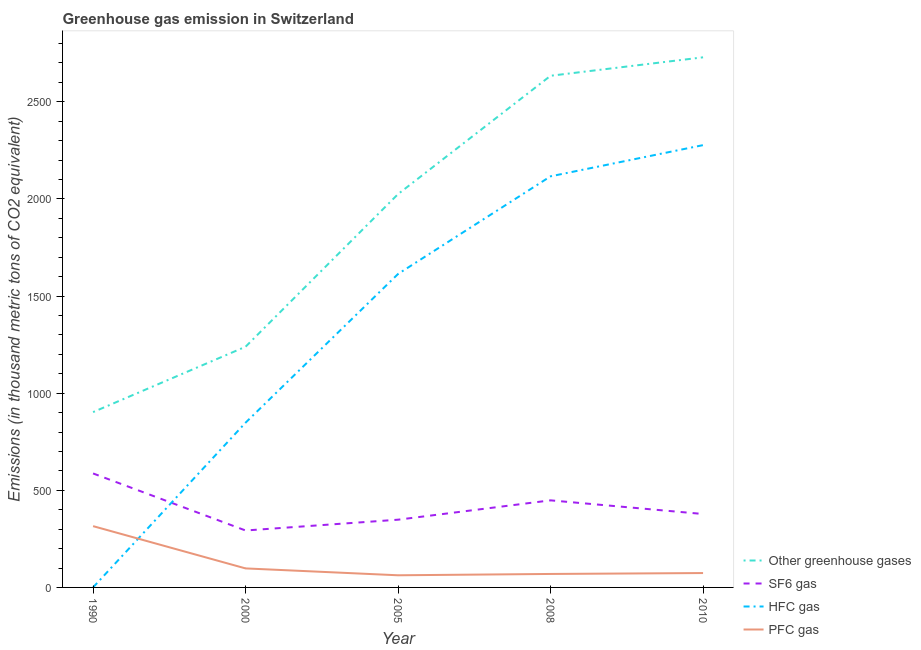Does the line corresponding to emission of hfc gas intersect with the line corresponding to emission of sf6 gas?
Make the answer very short. Yes. What is the emission of hfc gas in 2008?
Give a very brief answer. 2116.4. Across all years, what is the maximum emission of pfc gas?
Provide a short and direct response. 315.5. Across all years, what is the minimum emission of sf6 gas?
Offer a very short reply. 293.1. In which year was the emission of sf6 gas maximum?
Ensure brevity in your answer.  1990. In which year was the emission of pfc gas minimum?
Offer a very short reply. 2005. What is the total emission of sf6 gas in the graph?
Give a very brief answer. 2054.9. What is the difference between the emission of greenhouse gases in 2000 and that in 2008?
Your response must be concise. -1394.9. What is the difference between the emission of pfc gas in 2000 and the emission of sf6 gas in 2008?
Make the answer very short. -350.4. What is the average emission of sf6 gas per year?
Keep it short and to the point. 410.98. In the year 2005, what is the difference between the emission of hfc gas and emission of sf6 gas?
Provide a succinct answer. 1265.1. What is the ratio of the emission of hfc gas in 1990 to that in 2005?
Keep it short and to the point. 0. Is the emission of pfc gas in 1990 less than that in 2005?
Keep it short and to the point. No. What is the difference between the highest and the second highest emission of pfc gas?
Your answer should be compact. 217.6. What is the difference between the highest and the lowest emission of sf6 gas?
Your response must be concise. 293.7. In how many years, is the emission of greenhouse gases greater than the average emission of greenhouse gases taken over all years?
Keep it short and to the point. 3. Is the sum of the emission of pfc gas in 1990 and 2000 greater than the maximum emission of sf6 gas across all years?
Offer a very short reply. No. Is it the case that in every year, the sum of the emission of sf6 gas and emission of greenhouse gases is greater than the sum of emission of pfc gas and emission of hfc gas?
Offer a terse response. Yes. Is it the case that in every year, the sum of the emission of greenhouse gases and emission of sf6 gas is greater than the emission of hfc gas?
Offer a very short reply. Yes. Does the emission of sf6 gas monotonically increase over the years?
Ensure brevity in your answer.  No. Is the emission of greenhouse gases strictly greater than the emission of pfc gas over the years?
Provide a short and direct response. Yes. How many years are there in the graph?
Your answer should be compact. 5. What is the difference between two consecutive major ticks on the Y-axis?
Your answer should be compact. 500. Are the values on the major ticks of Y-axis written in scientific E-notation?
Offer a terse response. No. Where does the legend appear in the graph?
Keep it short and to the point. Bottom right. How many legend labels are there?
Make the answer very short. 4. What is the title of the graph?
Offer a very short reply. Greenhouse gas emission in Switzerland. Does "Debt policy" appear as one of the legend labels in the graph?
Offer a very short reply. No. What is the label or title of the Y-axis?
Make the answer very short. Emissions (in thousand metric tons of CO2 equivalent). What is the Emissions (in thousand metric tons of CO2 equivalent) of Other greenhouse gases in 1990?
Provide a succinct answer. 902.6. What is the Emissions (in thousand metric tons of CO2 equivalent) of SF6 gas in 1990?
Your response must be concise. 586.8. What is the Emissions (in thousand metric tons of CO2 equivalent) of PFC gas in 1990?
Give a very brief answer. 315.5. What is the Emissions (in thousand metric tons of CO2 equivalent) of Other greenhouse gases in 2000?
Provide a short and direct response. 1239.2. What is the Emissions (in thousand metric tons of CO2 equivalent) in SF6 gas in 2000?
Keep it short and to the point. 293.1. What is the Emissions (in thousand metric tons of CO2 equivalent) in HFC gas in 2000?
Provide a succinct answer. 848.2. What is the Emissions (in thousand metric tons of CO2 equivalent) in PFC gas in 2000?
Provide a short and direct response. 97.9. What is the Emissions (in thousand metric tons of CO2 equivalent) in Other greenhouse gases in 2005?
Your response must be concise. 2025. What is the Emissions (in thousand metric tons of CO2 equivalent) in SF6 gas in 2005?
Your answer should be compact. 348.7. What is the Emissions (in thousand metric tons of CO2 equivalent) of HFC gas in 2005?
Your response must be concise. 1613.8. What is the Emissions (in thousand metric tons of CO2 equivalent) in PFC gas in 2005?
Make the answer very short. 62.5. What is the Emissions (in thousand metric tons of CO2 equivalent) of Other greenhouse gases in 2008?
Provide a succinct answer. 2634.1. What is the Emissions (in thousand metric tons of CO2 equivalent) in SF6 gas in 2008?
Provide a short and direct response. 448.3. What is the Emissions (in thousand metric tons of CO2 equivalent) of HFC gas in 2008?
Offer a very short reply. 2116.4. What is the Emissions (in thousand metric tons of CO2 equivalent) of PFC gas in 2008?
Offer a terse response. 69.4. What is the Emissions (in thousand metric tons of CO2 equivalent) of Other greenhouse gases in 2010?
Make the answer very short. 2729. What is the Emissions (in thousand metric tons of CO2 equivalent) in SF6 gas in 2010?
Offer a terse response. 378. What is the Emissions (in thousand metric tons of CO2 equivalent) in HFC gas in 2010?
Ensure brevity in your answer.  2277. What is the Emissions (in thousand metric tons of CO2 equivalent) in PFC gas in 2010?
Offer a very short reply. 74. Across all years, what is the maximum Emissions (in thousand metric tons of CO2 equivalent) in Other greenhouse gases?
Provide a succinct answer. 2729. Across all years, what is the maximum Emissions (in thousand metric tons of CO2 equivalent) of SF6 gas?
Give a very brief answer. 586.8. Across all years, what is the maximum Emissions (in thousand metric tons of CO2 equivalent) of HFC gas?
Keep it short and to the point. 2277. Across all years, what is the maximum Emissions (in thousand metric tons of CO2 equivalent) in PFC gas?
Your answer should be compact. 315.5. Across all years, what is the minimum Emissions (in thousand metric tons of CO2 equivalent) of Other greenhouse gases?
Offer a terse response. 902.6. Across all years, what is the minimum Emissions (in thousand metric tons of CO2 equivalent) in SF6 gas?
Your answer should be very brief. 293.1. Across all years, what is the minimum Emissions (in thousand metric tons of CO2 equivalent) of PFC gas?
Provide a short and direct response. 62.5. What is the total Emissions (in thousand metric tons of CO2 equivalent) of Other greenhouse gases in the graph?
Your answer should be compact. 9529.9. What is the total Emissions (in thousand metric tons of CO2 equivalent) of SF6 gas in the graph?
Ensure brevity in your answer.  2054.9. What is the total Emissions (in thousand metric tons of CO2 equivalent) in HFC gas in the graph?
Offer a very short reply. 6855.7. What is the total Emissions (in thousand metric tons of CO2 equivalent) of PFC gas in the graph?
Your response must be concise. 619.3. What is the difference between the Emissions (in thousand metric tons of CO2 equivalent) of Other greenhouse gases in 1990 and that in 2000?
Provide a succinct answer. -336.6. What is the difference between the Emissions (in thousand metric tons of CO2 equivalent) in SF6 gas in 1990 and that in 2000?
Keep it short and to the point. 293.7. What is the difference between the Emissions (in thousand metric tons of CO2 equivalent) in HFC gas in 1990 and that in 2000?
Offer a terse response. -847.9. What is the difference between the Emissions (in thousand metric tons of CO2 equivalent) of PFC gas in 1990 and that in 2000?
Your answer should be compact. 217.6. What is the difference between the Emissions (in thousand metric tons of CO2 equivalent) in Other greenhouse gases in 1990 and that in 2005?
Your response must be concise. -1122.4. What is the difference between the Emissions (in thousand metric tons of CO2 equivalent) in SF6 gas in 1990 and that in 2005?
Ensure brevity in your answer.  238.1. What is the difference between the Emissions (in thousand metric tons of CO2 equivalent) of HFC gas in 1990 and that in 2005?
Make the answer very short. -1613.5. What is the difference between the Emissions (in thousand metric tons of CO2 equivalent) in PFC gas in 1990 and that in 2005?
Offer a very short reply. 253. What is the difference between the Emissions (in thousand metric tons of CO2 equivalent) of Other greenhouse gases in 1990 and that in 2008?
Your response must be concise. -1731.5. What is the difference between the Emissions (in thousand metric tons of CO2 equivalent) in SF6 gas in 1990 and that in 2008?
Your response must be concise. 138.5. What is the difference between the Emissions (in thousand metric tons of CO2 equivalent) in HFC gas in 1990 and that in 2008?
Offer a very short reply. -2116.1. What is the difference between the Emissions (in thousand metric tons of CO2 equivalent) in PFC gas in 1990 and that in 2008?
Provide a short and direct response. 246.1. What is the difference between the Emissions (in thousand metric tons of CO2 equivalent) of Other greenhouse gases in 1990 and that in 2010?
Offer a terse response. -1826.4. What is the difference between the Emissions (in thousand metric tons of CO2 equivalent) in SF6 gas in 1990 and that in 2010?
Your answer should be compact. 208.8. What is the difference between the Emissions (in thousand metric tons of CO2 equivalent) of HFC gas in 1990 and that in 2010?
Provide a succinct answer. -2276.7. What is the difference between the Emissions (in thousand metric tons of CO2 equivalent) in PFC gas in 1990 and that in 2010?
Provide a short and direct response. 241.5. What is the difference between the Emissions (in thousand metric tons of CO2 equivalent) in Other greenhouse gases in 2000 and that in 2005?
Provide a short and direct response. -785.8. What is the difference between the Emissions (in thousand metric tons of CO2 equivalent) of SF6 gas in 2000 and that in 2005?
Your answer should be compact. -55.6. What is the difference between the Emissions (in thousand metric tons of CO2 equivalent) of HFC gas in 2000 and that in 2005?
Your answer should be compact. -765.6. What is the difference between the Emissions (in thousand metric tons of CO2 equivalent) of PFC gas in 2000 and that in 2005?
Your response must be concise. 35.4. What is the difference between the Emissions (in thousand metric tons of CO2 equivalent) in Other greenhouse gases in 2000 and that in 2008?
Offer a terse response. -1394.9. What is the difference between the Emissions (in thousand metric tons of CO2 equivalent) in SF6 gas in 2000 and that in 2008?
Your response must be concise. -155.2. What is the difference between the Emissions (in thousand metric tons of CO2 equivalent) of HFC gas in 2000 and that in 2008?
Your answer should be compact. -1268.2. What is the difference between the Emissions (in thousand metric tons of CO2 equivalent) of PFC gas in 2000 and that in 2008?
Your response must be concise. 28.5. What is the difference between the Emissions (in thousand metric tons of CO2 equivalent) of Other greenhouse gases in 2000 and that in 2010?
Offer a very short reply. -1489.8. What is the difference between the Emissions (in thousand metric tons of CO2 equivalent) in SF6 gas in 2000 and that in 2010?
Offer a terse response. -84.9. What is the difference between the Emissions (in thousand metric tons of CO2 equivalent) of HFC gas in 2000 and that in 2010?
Your answer should be very brief. -1428.8. What is the difference between the Emissions (in thousand metric tons of CO2 equivalent) of PFC gas in 2000 and that in 2010?
Give a very brief answer. 23.9. What is the difference between the Emissions (in thousand metric tons of CO2 equivalent) of Other greenhouse gases in 2005 and that in 2008?
Offer a terse response. -609.1. What is the difference between the Emissions (in thousand metric tons of CO2 equivalent) in SF6 gas in 2005 and that in 2008?
Your answer should be compact. -99.6. What is the difference between the Emissions (in thousand metric tons of CO2 equivalent) in HFC gas in 2005 and that in 2008?
Give a very brief answer. -502.6. What is the difference between the Emissions (in thousand metric tons of CO2 equivalent) of PFC gas in 2005 and that in 2008?
Make the answer very short. -6.9. What is the difference between the Emissions (in thousand metric tons of CO2 equivalent) in Other greenhouse gases in 2005 and that in 2010?
Offer a terse response. -704. What is the difference between the Emissions (in thousand metric tons of CO2 equivalent) of SF6 gas in 2005 and that in 2010?
Your response must be concise. -29.3. What is the difference between the Emissions (in thousand metric tons of CO2 equivalent) of HFC gas in 2005 and that in 2010?
Keep it short and to the point. -663.2. What is the difference between the Emissions (in thousand metric tons of CO2 equivalent) in PFC gas in 2005 and that in 2010?
Your response must be concise. -11.5. What is the difference between the Emissions (in thousand metric tons of CO2 equivalent) in Other greenhouse gases in 2008 and that in 2010?
Offer a very short reply. -94.9. What is the difference between the Emissions (in thousand metric tons of CO2 equivalent) in SF6 gas in 2008 and that in 2010?
Provide a short and direct response. 70.3. What is the difference between the Emissions (in thousand metric tons of CO2 equivalent) of HFC gas in 2008 and that in 2010?
Provide a succinct answer. -160.6. What is the difference between the Emissions (in thousand metric tons of CO2 equivalent) in Other greenhouse gases in 1990 and the Emissions (in thousand metric tons of CO2 equivalent) in SF6 gas in 2000?
Offer a very short reply. 609.5. What is the difference between the Emissions (in thousand metric tons of CO2 equivalent) in Other greenhouse gases in 1990 and the Emissions (in thousand metric tons of CO2 equivalent) in HFC gas in 2000?
Offer a very short reply. 54.4. What is the difference between the Emissions (in thousand metric tons of CO2 equivalent) in Other greenhouse gases in 1990 and the Emissions (in thousand metric tons of CO2 equivalent) in PFC gas in 2000?
Ensure brevity in your answer.  804.7. What is the difference between the Emissions (in thousand metric tons of CO2 equivalent) of SF6 gas in 1990 and the Emissions (in thousand metric tons of CO2 equivalent) of HFC gas in 2000?
Offer a very short reply. -261.4. What is the difference between the Emissions (in thousand metric tons of CO2 equivalent) of SF6 gas in 1990 and the Emissions (in thousand metric tons of CO2 equivalent) of PFC gas in 2000?
Offer a terse response. 488.9. What is the difference between the Emissions (in thousand metric tons of CO2 equivalent) of HFC gas in 1990 and the Emissions (in thousand metric tons of CO2 equivalent) of PFC gas in 2000?
Your answer should be very brief. -97.6. What is the difference between the Emissions (in thousand metric tons of CO2 equivalent) in Other greenhouse gases in 1990 and the Emissions (in thousand metric tons of CO2 equivalent) in SF6 gas in 2005?
Provide a succinct answer. 553.9. What is the difference between the Emissions (in thousand metric tons of CO2 equivalent) in Other greenhouse gases in 1990 and the Emissions (in thousand metric tons of CO2 equivalent) in HFC gas in 2005?
Your answer should be very brief. -711.2. What is the difference between the Emissions (in thousand metric tons of CO2 equivalent) of Other greenhouse gases in 1990 and the Emissions (in thousand metric tons of CO2 equivalent) of PFC gas in 2005?
Offer a very short reply. 840.1. What is the difference between the Emissions (in thousand metric tons of CO2 equivalent) of SF6 gas in 1990 and the Emissions (in thousand metric tons of CO2 equivalent) of HFC gas in 2005?
Offer a terse response. -1027. What is the difference between the Emissions (in thousand metric tons of CO2 equivalent) of SF6 gas in 1990 and the Emissions (in thousand metric tons of CO2 equivalent) of PFC gas in 2005?
Your answer should be very brief. 524.3. What is the difference between the Emissions (in thousand metric tons of CO2 equivalent) of HFC gas in 1990 and the Emissions (in thousand metric tons of CO2 equivalent) of PFC gas in 2005?
Offer a terse response. -62.2. What is the difference between the Emissions (in thousand metric tons of CO2 equivalent) in Other greenhouse gases in 1990 and the Emissions (in thousand metric tons of CO2 equivalent) in SF6 gas in 2008?
Your answer should be compact. 454.3. What is the difference between the Emissions (in thousand metric tons of CO2 equivalent) of Other greenhouse gases in 1990 and the Emissions (in thousand metric tons of CO2 equivalent) of HFC gas in 2008?
Make the answer very short. -1213.8. What is the difference between the Emissions (in thousand metric tons of CO2 equivalent) in Other greenhouse gases in 1990 and the Emissions (in thousand metric tons of CO2 equivalent) in PFC gas in 2008?
Offer a terse response. 833.2. What is the difference between the Emissions (in thousand metric tons of CO2 equivalent) in SF6 gas in 1990 and the Emissions (in thousand metric tons of CO2 equivalent) in HFC gas in 2008?
Offer a terse response. -1529.6. What is the difference between the Emissions (in thousand metric tons of CO2 equivalent) in SF6 gas in 1990 and the Emissions (in thousand metric tons of CO2 equivalent) in PFC gas in 2008?
Your response must be concise. 517.4. What is the difference between the Emissions (in thousand metric tons of CO2 equivalent) of HFC gas in 1990 and the Emissions (in thousand metric tons of CO2 equivalent) of PFC gas in 2008?
Make the answer very short. -69.1. What is the difference between the Emissions (in thousand metric tons of CO2 equivalent) of Other greenhouse gases in 1990 and the Emissions (in thousand metric tons of CO2 equivalent) of SF6 gas in 2010?
Provide a short and direct response. 524.6. What is the difference between the Emissions (in thousand metric tons of CO2 equivalent) in Other greenhouse gases in 1990 and the Emissions (in thousand metric tons of CO2 equivalent) in HFC gas in 2010?
Give a very brief answer. -1374.4. What is the difference between the Emissions (in thousand metric tons of CO2 equivalent) in Other greenhouse gases in 1990 and the Emissions (in thousand metric tons of CO2 equivalent) in PFC gas in 2010?
Keep it short and to the point. 828.6. What is the difference between the Emissions (in thousand metric tons of CO2 equivalent) of SF6 gas in 1990 and the Emissions (in thousand metric tons of CO2 equivalent) of HFC gas in 2010?
Offer a terse response. -1690.2. What is the difference between the Emissions (in thousand metric tons of CO2 equivalent) of SF6 gas in 1990 and the Emissions (in thousand metric tons of CO2 equivalent) of PFC gas in 2010?
Ensure brevity in your answer.  512.8. What is the difference between the Emissions (in thousand metric tons of CO2 equivalent) of HFC gas in 1990 and the Emissions (in thousand metric tons of CO2 equivalent) of PFC gas in 2010?
Your answer should be compact. -73.7. What is the difference between the Emissions (in thousand metric tons of CO2 equivalent) in Other greenhouse gases in 2000 and the Emissions (in thousand metric tons of CO2 equivalent) in SF6 gas in 2005?
Your answer should be compact. 890.5. What is the difference between the Emissions (in thousand metric tons of CO2 equivalent) of Other greenhouse gases in 2000 and the Emissions (in thousand metric tons of CO2 equivalent) of HFC gas in 2005?
Ensure brevity in your answer.  -374.6. What is the difference between the Emissions (in thousand metric tons of CO2 equivalent) of Other greenhouse gases in 2000 and the Emissions (in thousand metric tons of CO2 equivalent) of PFC gas in 2005?
Offer a terse response. 1176.7. What is the difference between the Emissions (in thousand metric tons of CO2 equivalent) of SF6 gas in 2000 and the Emissions (in thousand metric tons of CO2 equivalent) of HFC gas in 2005?
Your answer should be compact. -1320.7. What is the difference between the Emissions (in thousand metric tons of CO2 equivalent) of SF6 gas in 2000 and the Emissions (in thousand metric tons of CO2 equivalent) of PFC gas in 2005?
Provide a short and direct response. 230.6. What is the difference between the Emissions (in thousand metric tons of CO2 equivalent) of HFC gas in 2000 and the Emissions (in thousand metric tons of CO2 equivalent) of PFC gas in 2005?
Provide a short and direct response. 785.7. What is the difference between the Emissions (in thousand metric tons of CO2 equivalent) in Other greenhouse gases in 2000 and the Emissions (in thousand metric tons of CO2 equivalent) in SF6 gas in 2008?
Your answer should be very brief. 790.9. What is the difference between the Emissions (in thousand metric tons of CO2 equivalent) of Other greenhouse gases in 2000 and the Emissions (in thousand metric tons of CO2 equivalent) of HFC gas in 2008?
Offer a very short reply. -877.2. What is the difference between the Emissions (in thousand metric tons of CO2 equivalent) in Other greenhouse gases in 2000 and the Emissions (in thousand metric tons of CO2 equivalent) in PFC gas in 2008?
Offer a terse response. 1169.8. What is the difference between the Emissions (in thousand metric tons of CO2 equivalent) in SF6 gas in 2000 and the Emissions (in thousand metric tons of CO2 equivalent) in HFC gas in 2008?
Offer a very short reply. -1823.3. What is the difference between the Emissions (in thousand metric tons of CO2 equivalent) of SF6 gas in 2000 and the Emissions (in thousand metric tons of CO2 equivalent) of PFC gas in 2008?
Give a very brief answer. 223.7. What is the difference between the Emissions (in thousand metric tons of CO2 equivalent) of HFC gas in 2000 and the Emissions (in thousand metric tons of CO2 equivalent) of PFC gas in 2008?
Give a very brief answer. 778.8. What is the difference between the Emissions (in thousand metric tons of CO2 equivalent) of Other greenhouse gases in 2000 and the Emissions (in thousand metric tons of CO2 equivalent) of SF6 gas in 2010?
Your answer should be very brief. 861.2. What is the difference between the Emissions (in thousand metric tons of CO2 equivalent) in Other greenhouse gases in 2000 and the Emissions (in thousand metric tons of CO2 equivalent) in HFC gas in 2010?
Give a very brief answer. -1037.8. What is the difference between the Emissions (in thousand metric tons of CO2 equivalent) of Other greenhouse gases in 2000 and the Emissions (in thousand metric tons of CO2 equivalent) of PFC gas in 2010?
Ensure brevity in your answer.  1165.2. What is the difference between the Emissions (in thousand metric tons of CO2 equivalent) in SF6 gas in 2000 and the Emissions (in thousand metric tons of CO2 equivalent) in HFC gas in 2010?
Your answer should be compact. -1983.9. What is the difference between the Emissions (in thousand metric tons of CO2 equivalent) of SF6 gas in 2000 and the Emissions (in thousand metric tons of CO2 equivalent) of PFC gas in 2010?
Keep it short and to the point. 219.1. What is the difference between the Emissions (in thousand metric tons of CO2 equivalent) in HFC gas in 2000 and the Emissions (in thousand metric tons of CO2 equivalent) in PFC gas in 2010?
Your answer should be very brief. 774.2. What is the difference between the Emissions (in thousand metric tons of CO2 equivalent) of Other greenhouse gases in 2005 and the Emissions (in thousand metric tons of CO2 equivalent) of SF6 gas in 2008?
Provide a succinct answer. 1576.7. What is the difference between the Emissions (in thousand metric tons of CO2 equivalent) of Other greenhouse gases in 2005 and the Emissions (in thousand metric tons of CO2 equivalent) of HFC gas in 2008?
Make the answer very short. -91.4. What is the difference between the Emissions (in thousand metric tons of CO2 equivalent) of Other greenhouse gases in 2005 and the Emissions (in thousand metric tons of CO2 equivalent) of PFC gas in 2008?
Offer a terse response. 1955.6. What is the difference between the Emissions (in thousand metric tons of CO2 equivalent) of SF6 gas in 2005 and the Emissions (in thousand metric tons of CO2 equivalent) of HFC gas in 2008?
Ensure brevity in your answer.  -1767.7. What is the difference between the Emissions (in thousand metric tons of CO2 equivalent) of SF6 gas in 2005 and the Emissions (in thousand metric tons of CO2 equivalent) of PFC gas in 2008?
Your answer should be compact. 279.3. What is the difference between the Emissions (in thousand metric tons of CO2 equivalent) of HFC gas in 2005 and the Emissions (in thousand metric tons of CO2 equivalent) of PFC gas in 2008?
Your answer should be very brief. 1544.4. What is the difference between the Emissions (in thousand metric tons of CO2 equivalent) in Other greenhouse gases in 2005 and the Emissions (in thousand metric tons of CO2 equivalent) in SF6 gas in 2010?
Keep it short and to the point. 1647. What is the difference between the Emissions (in thousand metric tons of CO2 equivalent) in Other greenhouse gases in 2005 and the Emissions (in thousand metric tons of CO2 equivalent) in HFC gas in 2010?
Offer a very short reply. -252. What is the difference between the Emissions (in thousand metric tons of CO2 equivalent) of Other greenhouse gases in 2005 and the Emissions (in thousand metric tons of CO2 equivalent) of PFC gas in 2010?
Ensure brevity in your answer.  1951. What is the difference between the Emissions (in thousand metric tons of CO2 equivalent) of SF6 gas in 2005 and the Emissions (in thousand metric tons of CO2 equivalent) of HFC gas in 2010?
Provide a succinct answer. -1928.3. What is the difference between the Emissions (in thousand metric tons of CO2 equivalent) of SF6 gas in 2005 and the Emissions (in thousand metric tons of CO2 equivalent) of PFC gas in 2010?
Provide a succinct answer. 274.7. What is the difference between the Emissions (in thousand metric tons of CO2 equivalent) of HFC gas in 2005 and the Emissions (in thousand metric tons of CO2 equivalent) of PFC gas in 2010?
Your answer should be very brief. 1539.8. What is the difference between the Emissions (in thousand metric tons of CO2 equivalent) in Other greenhouse gases in 2008 and the Emissions (in thousand metric tons of CO2 equivalent) in SF6 gas in 2010?
Make the answer very short. 2256.1. What is the difference between the Emissions (in thousand metric tons of CO2 equivalent) in Other greenhouse gases in 2008 and the Emissions (in thousand metric tons of CO2 equivalent) in HFC gas in 2010?
Keep it short and to the point. 357.1. What is the difference between the Emissions (in thousand metric tons of CO2 equivalent) in Other greenhouse gases in 2008 and the Emissions (in thousand metric tons of CO2 equivalent) in PFC gas in 2010?
Make the answer very short. 2560.1. What is the difference between the Emissions (in thousand metric tons of CO2 equivalent) of SF6 gas in 2008 and the Emissions (in thousand metric tons of CO2 equivalent) of HFC gas in 2010?
Provide a succinct answer. -1828.7. What is the difference between the Emissions (in thousand metric tons of CO2 equivalent) of SF6 gas in 2008 and the Emissions (in thousand metric tons of CO2 equivalent) of PFC gas in 2010?
Ensure brevity in your answer.  374.3. What is the difference between the Emissions (in thousand metric tons of CO2 equivalent) in HFC gas in 2008 and the Emissions (in thousand metric tons of CO2 equivalent) in PFC gas in 2010?
Provide a short and direct response. 2042.4. What is the average Emissions (in thousand metric tons of CO2 equivalent) in Other greenhouse gases per year?
Provide a short and direct response. 1905.98. What is the average Emissions (in thousand metric tons of CO2 equivalent) in SF6 gas per year?
Give a very brief answer. 410.98. What is the average Emissions (in thousand metric tons of CO2 equivalent) in HFC gas per year?
Your answer should be compact. 1371.14. What is the average Emissions (in thousand metric tons of CO2 equivalent) in PFC gas per year?
Ensure brevity in your answer.  123.86. In the year 1990, what is the difference between the Emissions (in thousand metric tons of CO2 equivalent) of Other greenhouse gases and Emissions (in thousand metric tons of CO2 equivalent) of SF6 gas?
Your answer should be compact. 315.8. In the year 1990, what is the difference between the Emissions (in thousand metric tons of CO2 equivalent) of Other greenhouse gases and Emissions (in thousand metric tons of CO2 equivalent) of HFC gas?
Give a very brief answer. 902.3. In the year 1990, what is the difference between the Emissions (in thousand metric tons of CO2 equivalent) in Other greenhouse gases and Emissions (in thousand metric tons of CO2 equivalent) in PFC gas?
Make the answer very short. 587.1. In the year 1990, what is the difference between the Emissions (in thousand metric tons of CO2 equivalent) in SF6 gas and Emissions (in thousand metric tons of CO2 equivalent) in HFC gas?
Offer a terse response. 586.5. In the year 1990, what is the difference between the Emissions (in thousand metric tons of CO2 equivalent) in SF6 gas and Emissions (in thousand metric tons of CO2 equivalent) in PFC gas?
Provide a short and direct response. 271.3. In the year 1990, what is the difference between the Emissions (in thousand metric tons of CO2 equivalent) of HFC gas and Emissions (in thousand metric tons of CO2 equivalent) of PFC gas?
Offer a terse response. -315.2. In the year 2000, what is the difference between the Emissions (in thousand metric tons of CO2 equivalent) of Other greenhouse gases and Emissions (in thousand metric tons of CO2 equivalent) of SF6 gas?
Your answer should be very brief. 946.1. In the year 2000, what is the difference between the Emissions (in thousand metric tons of CO2 equivalent) in Other greenhouse gases and Emissions (in thousand metric tons of CO2 equivalent) in HFC gas?
Your answer should be very brief. 391. In the year 2000, what is the difference between the Emissions (in thousand metric tons of CO2 equivalent) of Other greenhouse gases and Emissions (in thousand metric tons of CO2 equivalent) of PFC gas?
Offer a very short reply. 1141.3. In the year 2000, what is the difference between the Emissions (in thousand metric tons of CO2 equivalent) of SF6 gas and Emissions (in thousand metric tons of CO2 equivalent) of HFC gas?
Make the answer very short. -555.1. In the year 2000, what is the difference between the Emissions (in thousand metric tons of CO2 equivalent) of SF6 gas and Emissions (in thousand metric tons of CO2 equivalent) of PFC gas?
Make the answer very short. 195.2. In the year 2000, what is the difference between the Emissions (in thousand metric tons of CO2 equivalent) of HFC gas and Emissions (in thousand metric tons of CO2 equivalent) of PFC gas?
Provide a succinct answer. 750.3. In the year 2005, what is the difference between the Emissions (in thousand metric tons of CO2 equivalent) in Other greenhouse gases and Emissions (in thousand metric tons of CO2 equivalent) in SF6 gas?
Make the answer very short. 1676.3. In the year 2005, what is the difference between the Emissions (in thousand metric tons of CO2 equivalent) of Other greenhouse gases and Emissions (in thousand metric tons of CO2 equivalent) of HFC gas?
Offer a terse response. 411.2. In the year 2005, what is the difference between the Emissions (in thousand metric tons of CO2 equivalent) in Other greenhouse gases and Emissions (in thousand metric tons of CO2 equivalent) in PFC gas?
Keep it short and to the point. 1962.5. In the year 2005, what is the difference between the Emissions (in thousand metric tons of CO2 equivalent) in SF6 gas and Emissions (in thousand metric tons of CO2 equivalent) in HFC gas?
Give a very brief answer. -1265.1. In the year 2005, what is the difference between the Emissions (in thousand metric tons of CO2 equivalent) of SF6 gas and Emissions (in thousand metric tons of CO2 equivalent) of PFC gas?
Provide a succinct answer. 286.2. In the year 2005, what is the difference between the Emissions (in thousand metric tons of CO2 equivalent) of HFC gas and Emissions (in thousand metric tons of CO2 equivalent) of PFC gas?
Your response must be concise. 1551.3. In the year 2008, what is the difference between the Emissions (in thousand metric tons of CO2 equivalent) in Other greenhouse gases and Emissions (in thousand metric tons of CO2 equivalent) in SF6 gas?
Keep it short and to the point. 2185.8. In the year 2008, what is the difference between the Emissions (in thousand metric tons of CO2 equivalent) in Other greenhouse gases and Emissions (in thousand metric tons of CO2 equivalent) in HFC gas?
Provide a short and direct response. 517.7. In the year 2008, what is the difference between the Emissions (in thousand metric tons of CO2 equivalent) of Other greenhouse gases and Emissions (in thousand metric tons of CO2 equivalent) of PFC gas?
Your response must be concise. 2564.7. In the year 2008, what is the difference between the Emissions (in thousand metric tons of CO2 equivalent) in SF6 gas and Emissions (in thousand metric tons of CO2 equivalent) in HFC gas?
Provide a short and direct response. -1668.1. In the year 2008, what is the difference between the Emissions (in thousand metric tons of CO2 equivalent) in SF6 gas and Emissions (in thousand metric tons of CO2 equivalent) in PFC gas?
Give a very brief answer. 378.9. In the year 2008, what is the difference between the Emissions (in thousand metric tons of CO2 equivalent) in HFC gas and Emissions (in thousand metric tons of CO2 equivalent) in PFC gas?
Offer a terse response. 2047. In the year 2010, what is the difference between the Emissions (in thousand metric tons of CO2 equivalent) of Other greenhouse gases and Emissions (in thousand metric tons of CO2 equivalent) of SF6 gas?
Your answer should be very brief. 2351. In the year 2010, what is the difference between the Emissions (in thousand metric tons of CO2 equivalent) in Other greenhouse gases and Emissions (in thousand metric tons of CO2 equivalent) in HFC gas?
Your answer should be compact. 452. In the year 2010, what is the difference between the Emissions (in thousand metric tons of CO2 equivalent) in Other greenhouse gases and Emissions (in thousand metric tons of CO2 equivalent) in PFC gas?
Ensure brevity in your answer.  2655. In the year 2010, what is the difference between the Emissions (in thousand metric tons of CO2 equivalent) of SF6 gas and Emissions (in thousand metric tons of CO2 equivalent) of HFC gas?
Offer a very short reply. -1899. In the year 2010, what is the difference between the Emissions (in thousand metric tons of CO2 equivalent) of SF6 gas and Emissions (in thousand metric tons of CO2 equivalent) of PFC gas?
Your answer should be compact. 304. In the year 2010, what is the difference between the Emissions (in thousand metric tons of CO2 equivalent) of HFC gas and Emissions (in thousand metric tons of CO2 equivalent) of PFC gas?
Provide a succinct answer. 2203. What is the ratio of the Emissions (in thousand metric tons of CO2 equivalent) in Other greenhouse gases in 1990 to that in 2000?
Your response must be concise. 0.73. What is the ratio of the Emissions (in thousand metric tons of CO2 equivalent) of SF6 gas in 1990 to that in 2000?
Offer a very short reply. 2. What is the ratio of the Emissions (in thousand metric tons of CO2 equivalent) of PFC gas in 1990 to that in 2000?
Offer a very short reply. 3.22. What is the ratio of the Emissions (in thousand metric tons of CO2 equivalent) of Other greenhouse gases in 1990 to that in 2005?
Your answer should be very brief. 0.45. What is the ratio of the Emissions (in thousand metric tons of CO2 equivalent) in SF6 gas in 1990 to that in 2005?
Your answer should be very brief. 1.68. What is the ratio of the Emissions (in thousand metric tons of CO2 equivalent) of HFC gas in 1990 to that in 2005?
Make the answer very short. 0. What is the ratio of the Emissions (in thousand metric tons of CO2 equivalent) of PFC gas in 1990 to that in 2005?
Give a very brief answer. 5.05. What is the ratio of the Emissions (in thousand metric tons of CO2 equivalent) in Other greenhouse gases in 1990 to that in 2008?
Provide a succinct answer. 0.34. What is the ratio of the Emissions (in thousand metric tons of CO2 equivalent) in SF6 gas in 1990 to that in 2008?
Your answer should be compact. 1.31. What is the ratio of the Emissions (in thousand metric tons of CO2 equivalent) in HFC gas in 1990 to that in 2008?
Make the answer very short. 0. What is the ratio of the Emissions (in thousand metric tons of CO2 equivalent) in PFC gas in 1990 to that in 2008?
Offer a terse response. 4.55. What is the ratio of the Emissions (in thousand metric tons of CO2 equivalent) in Other greenhouse gases in 1990 to that in 2010?
Provide a succinct answer. 0.33. What is the ratio of the Emissions (in thousand metric tons of CO2 equivalent) in SF6 gas in 1990 to that in 2010?
Your response must be concise. 1.55. What is the ratio of the Emissions (in thousand metric tons of CO2 equivalent) in HFC gas in 1990 to that in 2010?
Your answer should be compact. 0. What is the ratio of the Emissions (in thousand metric tons of CO2 equivalent) of PFC gas in 1990 to that in 2010?
Your response must be concise. 4.26. What is the ratio of the Emissions (in thousand metric tons of CO2 equivalent) in Other greenhouse gases in 2000 to that in 2005?
Your answer should be compact. 0.61. What is the ratio of the Emissions (in thousand metric tons of CO2 equivalent) in SF6 gas in 2000 to that in 2005?
Offer a very short reply. 0.84. What is the ratio of the Emissions (in thousand metric tons of CO2 equivalent) of HFC gas in 2000 to that in 2005?
Ensure brevity in your answer.  0.53. What is the ratio of the Emissions (in thousand metric tons of CO2 equivalent) of PFC gas in 2000 to that in 2005?
Offer a very short reply. 1.57. What is the ratio of the Emissions (in thousand metric tons of CO2 equivalent) of Other greenhouse gases in 2000 to that in 2008?
Provide a short and direct response. 0.47. What is the ratio of the Emissions (in thousand metric tons of CO2 equivalent) of SF6 gas in 2000 to that in 2008?
Offer a very short reply. 0.65. What is the ratio of the Emissions (in thousand metric tons of CO2 equivalent) of HFC gas in 2000 to that in 2008?
Your answer should be very brief. 0.4. What is the ratio of the Emissions (in thousand metric tons of CO2 equivalent) of PFC gas in 2000 to that in 2008?
Ensure brevity in your answer.  1.41. What is the ratio of the Emissions (in thousand metric tons of CO2 equivalent) in Other greenhouse gases in 2000 to that in 2010?
Provide a short and direct response. 0.45. What is the ratio of the Emissions (in thousand metric tons of CO2 equivalent) in SF6 gas in 2000 to that in 2010?
Provide a succinct answer. 0.78. What is the ratio of the Emissions (in thousand metric tons of CO2 equivalent) in HFC gas in 2000 to that in 2010?
Your answer should be very brief. 0.37. What is the ratio of the Emissions (in thousand metric tons of CO2 equivalent) of PFC gas in 2000 to that in 2010?
Offer a terse response. 1.32. What is the ratio of the Emissions (in thousand metric tons of CO2 equivalent) in Other greenhouse gases in 2005 to that in 2008?
Provide a succinct answer. 0.77. What is the ratio of the Emissions (in thousand metric tons of CO2 equivalent) in SF6 gas in 2005 to that in 2008?
Provide a short and direct response. 0.78. What is the ratio of the Emissions (in thousand metric tons of CO2 equivalent) in HFC gas in 2005 to that in 2008?
Ensure brevity in your answer.  0.76. What is the ratio of the Emissions (in thousand metric tons of CO2 equivalent) in PFC gas in 2005 to that in 2008?
Offer a terse response. 0.9. What is the ratio of the Emissions (in thousand metric tons of CO2 equivalent) in Other greenhouse gases in 2005 to that in 2010?
Offer a terse response. 0.74. What is the ratio of the Emissions (in thousand metric tons of CO2 equivalent) of SF6 gas in 2005 to that in 2010?
Your response must be concise. 0.92. What is the ratio of the Emissions (in thousand metric tons of CO2 equivalent) in HFC gas in 2005 to that in 2010?
Make the answer very short. 0.71. What is the ratio of the Emissions (in thousand metric tons of CO2 equivalent) of PFC gas in 2005 to that in 2010?
Your response must be concise. 0.84. What is the ratio of the Emissions (in thousand metric tons of CO2 equivalent) of Other greenhouse gases in 2008 to that in 2010?
Your response must be concise. 0.97. What is the ratio of the Emissions (in thousand metric tons of CO2 equivalent) in SF6 gas in 2008 to that in 2010?
Keep it short and to the point. 1.19. What is the ratio of the Emissions (in thousand metric tons of CO2 equivalent) of HFC gas in 2008 to that in 2010?
Your response must be concise. 0.93. What is the ratio of the Emissions (in thousand metric tons of CO2 equivalent) in PFC gas in 2008 to that in 2010?
Your answer should be very brief. 0.94. What is the difference between the highest and the second highest Emissions (in thousand metric tons of CO2 equivalent) of Other greenhouse gases?
Your response must be concise. 94.9. What is the difference between the highest and the second highest Emissions (in thousand metric tons of CO2 equivalent) in SF6 gas?
Provide a succinct answer. 138.5. What is the difference between the highest and the second highest Emissions (in thousand metric tons of CO2 equivalent) in HFC gas?
Give a very brief answer. 160.6. What is the difference between the highest and the second highest Emissions (in thousand metric tons of CO2 equivalent) in PFC gas?
Offer a very short reply. 217.6. What is the difference between the highest and the lowest Emissions (in thousand metric tons of CO2 equivalent) of Other greenhouse gases?
Ensure brevity in your answer.  1826.4. What is the difference between the highest and the lowest Emissions (in thousand metric tons of CO2 equivalent) of SF6 gas?
Your answer should be very brief. 293.7. What is the difference between the highest and the lowest Emissions (in thousand metric tons of CO2 equivalent) of HFC gas?
Give a very brief answer. 2276.7. What is the difference between the highest and the lowest Emissions (in thousand metric tons of CO2 equivalent) of PFC gas?
Your answer should be compact. 253. 